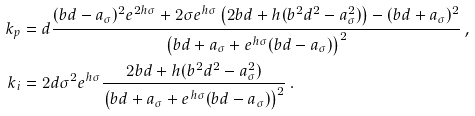<formula> <loc_0><loc_0><loc_500><loc_500>k _ { p } & = d \frac { ( b d - a _ { \sigma } ) ^ { 2 } e ^ { 2 h \sigma } + 2 \sigma e ^ { h \sigma } \left ( 2 b d + h ( b ^ { 2 } d ^ { 2 } - a _ { \sigma } ^ { 2 } ) \right ) - ( b d + a _ { \sigma } ) ^ { 2 } } { \left ( b d + a _ { \sigma } + e ^ { h \sigma } ( b d - a _ { \sigma } ) \right ) ^ { 2 } } \, , \\ k _ { i } & = 2 d \sigma ^ { 2 } e ^ { h \sigma } \frac { 2 b d + h ( b ^ { 2 } d ^ { 2 } - a _ { \sigma } ^ { 2 } ) } { \left ( b d + a _ { \sigma } + e ^ { h \sigma } ( b d - a _ { \sigma } ) \right ) ^ { 2 } } \, .</formula> 